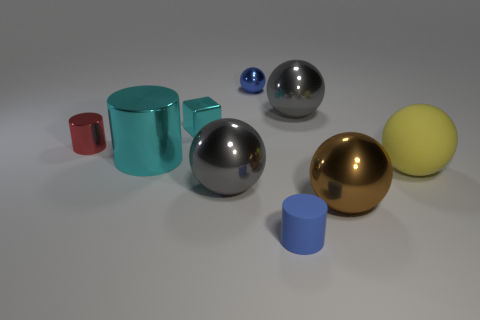The large cyan thing has what shape?
Your response must be concise. Cylinder. There is a tiny thing in front of the yellow sphere in front of the blue sphere; what shape is it?
Offer a terse response. Cylinder. What number of objects are either small blue metallic spheres or big things that are in front of the tiny red thing?
Your answer should be very brief. 5. What is the color of the large shiny sphere that is right of the large gray ball that is to the right of the tiny blue thing that is in front of the big yellow sphere?
Your answer should be compact. Brown. What is the material of the other large thing that is the same shape as the blue rubber object?
Your answer should be compact. Metal. What is the color of the big cylinder?
Provide a short and direct response. Cyan. Do the small matte object and the small ball have the same color?
Offer a terse response. Yes. What number of matte things are small cubes or small purple things?
Offer a terse response. 0. There is a gray metallic ball on the right side of the rubber thing left of the yellow matte object; are there any large gray metallic things behind it?
Provide a short and direct response. No. There is a cyan cylinder that is made of the same material as the big brown ball; what size is it?
Your answer should be very brief. Large. 